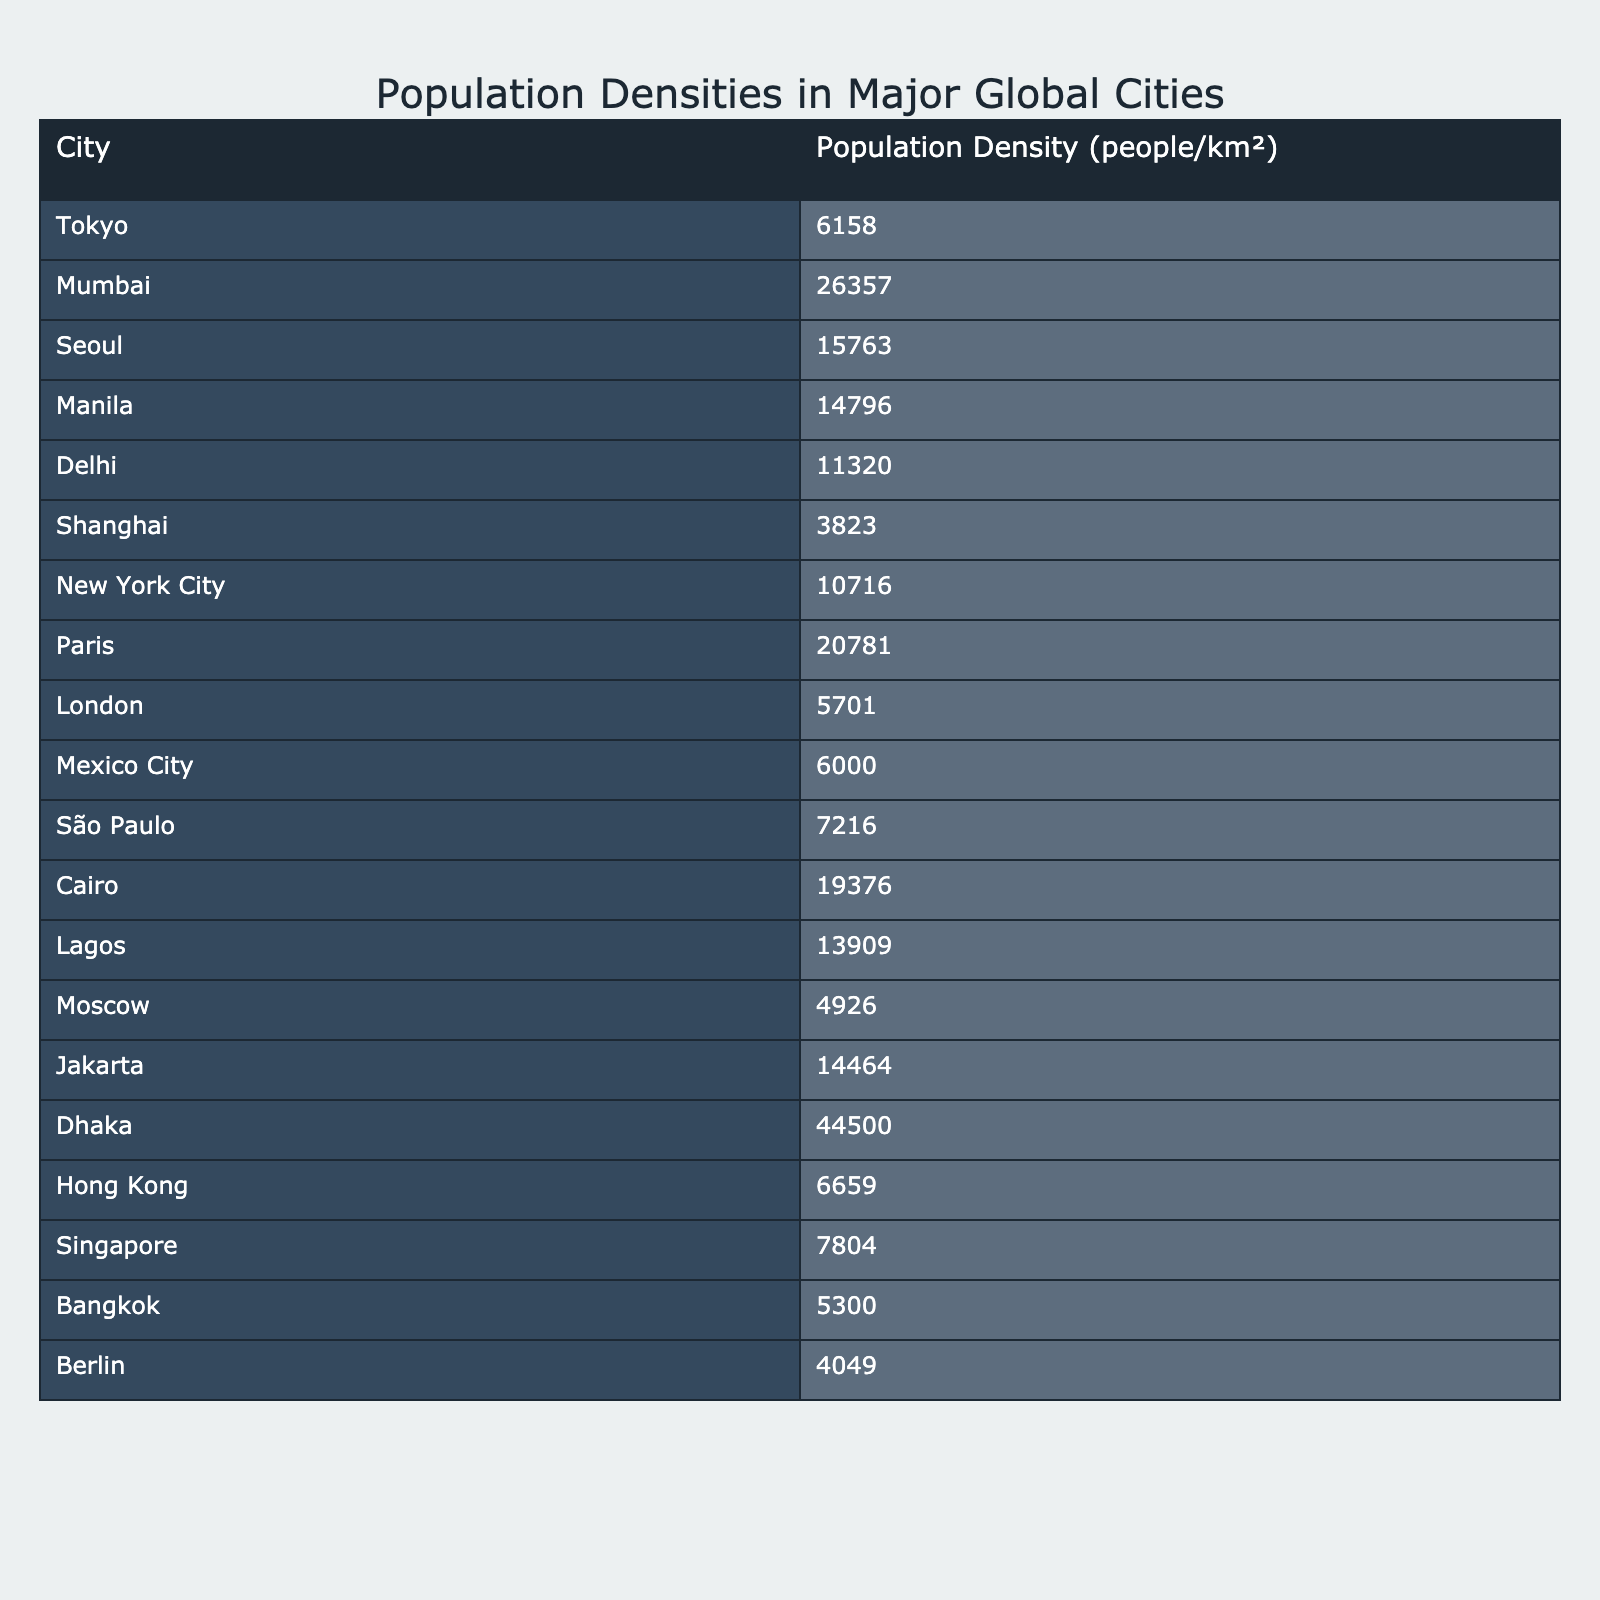What is the population density of Dhaka? The table states that Dhaka has a population density of 44,500 people/km², which is found under the column for 'Population Density' corresponding to the row for Dhaka.
Answer: 44,500 Which city has the highest population density? By reviewing the population densities listed in the table, Dhaka is identified as having the highest density of 44,500 people/km².
Answer: Dhaka What is the population density difference between Tokyo and Shanghai? From the table, Tokyo has a population density of 6,158 people/km² and Shanghai has 3,823 people/km². The difference is calculated by subtracting Shanghai's density from Tokyo's, giving 6,158 - 3,823 = 2,335.
Answer: 2,335 What are the cities with a population density greater than 20,000 people/km²? Checking the table reveals that only Paris exceeds this threshold, having a density of 20,781 people/km². Other cities do not meet this criterion.
Answer: Paris What is the average population density of all cities listed? To find the average, sum all densities (6158 + 26357 + 15763 + 14796 + 11320 + 3823 + 10716 + 20781 + 5701 + 6000 + 7216 + 19376 + 13909 + 4926 + 14464 + 6659 + 7804 + 5300 + 4049 = 146,691) and divide by the number of cities (18), resulting in an average of 146,691 / 18 ≈ 8,149.5.
Answer: 8,149.5 Is the population density of New York City greater than that of London? The table indicates New York City has a population density of 10,716 people/km², while London has 5,701 people/km². Since 10,716 > 5,701, the answer is affirmative.
Answer: Yes How many cities have a population density between 10,000 and 20,000 people/km²? The cities within this range from the table include Delhi (11,320), New York City (10,716), Cairo (19,376), and Manila (14,796). Counting these gives 4 cities.
Answer: 4 Which city has the second lowest population density? The first lowest population density is Shanghai at 3,823 people/km², and by comparing the rest, the second lowest density is Moscow with 4,926 people/km², as it is the next lowest after Shanghai.
Answer: Moscow Which two cities have the most similar population densities? By comparing the population densities, Singapore (7,804) and São Paulo (7,216) are the most similar with a difference of only 588 people/km².
Answer: Singapore and São Paulo What percentage of the highest population density does Tokyo represent? Tokyo has a density of 6,158 people/km², and the highest is Dhaka at 44,500 people/km². The percentage is calculated as (6,158 / 44,500) * 100 ≈ 13.84%.
Answer: 13.84% 